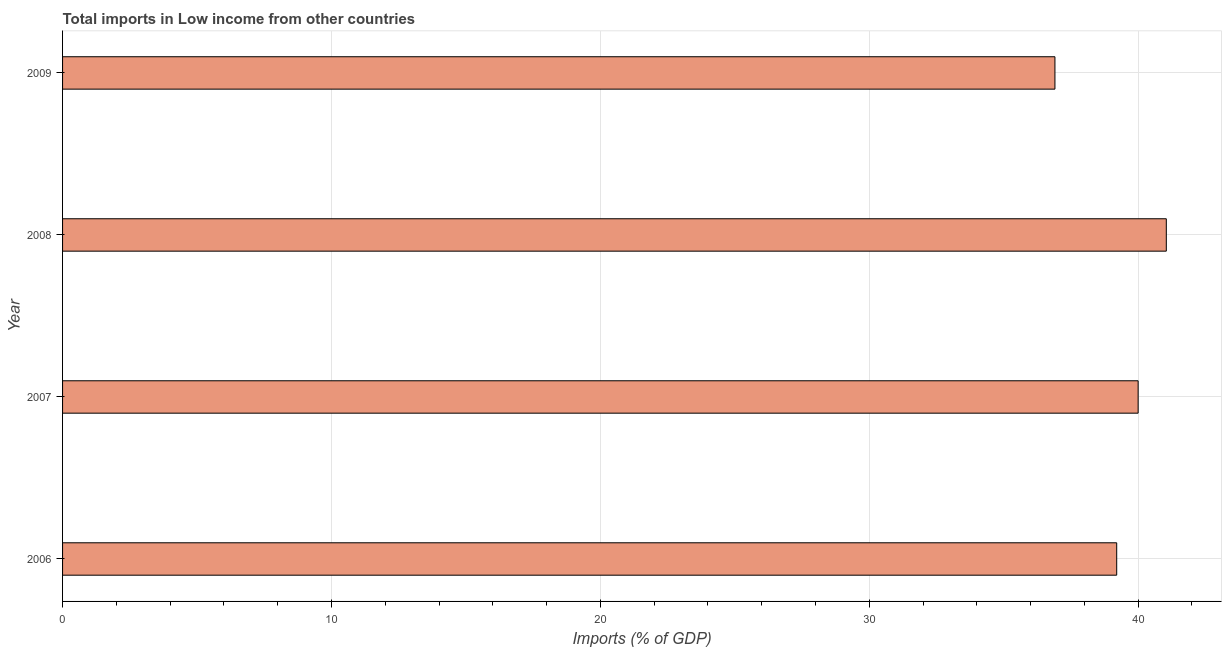Does the graph contain grids?
Your response must be concise. Yes. What is the title of the graph?
Offer a very short reply. Total imports in Low income from other countries. What is the label or title of the X-axis?
Ensure brevity in your answer.  Imports (% of GDP). What is the total imports in 2008?
Ensure brevity in your answer.  41.05. Across all years, what is the maximum total imports?
Offer a terse response. 41.05. Across all years, what is the minimum total imports?
Give a very brief answer. 36.91. In which year was the total imports maximum?
Offer a very short reply. 2008. In which year was the total imports minimum?
Offer a very short reply. 2009. What is the sum of the total imports?
Ensure brevity in your answer.  157.16. What is the difference between the total imports in 2007 and 2009?
Make the answer very short. 3.09. What is the average total imports per year?
Keep it short and to the point. 39.29. What is the median total imports?
Keep it short and to the point. 39.6. Do a majority of the years between 2009 and 2007 (inclusive) have total imports greater than 8 %?
Keep it short and to the point. Yes. What is the ratio of the total imports in 2006 to that in 2009?
Offer a very short reply. 1.06. Is the total imports in 2006 less than that in 2007?
Provide a short and direct response. Yes. Is the difference between the total imports in 2006 and 2007 greater than the difference between any two years?
Make the answer very short. No. What is the difference between the highest and the second highest total imports?
Give a very brief answer. 1.05. What is the difference between the highest and the lowest total imports?
Provide a short and direct response. 4.14. How many bars are there?
Offer a very short reply. 4. What is the difference between two consecutive major ticks on the X-axis?
Your answer should be compact. 10. Are the values on the major ticks of X-axis written in scientific E-notation?
Provide a succinct answer. No. What is the Imports (% of GDP) of 2006?
Your answer should be compact. 39.2. What is the Imports (% of GDP) of 2007?
Your answer should be very brief. 40. What is the Imports (% of GDP) of 2008?
Provide a succinct answer. 41.05. What is the Imports (% of GDP) of 2009?
Keep it short and to the point. 36.91. What is the difference between the Imports (% of GDP) in 2006 and 2007?
Keep it short and to the point. -0.8. What is the difference between the Imports (% of GDP) in 2006 and 2008?
Offer a terse response. -1.84. What is the difference between the Imports (% of GDP) in 2006 and 2009?
Offer a very short reply. 2.3. What is the difference between the Imports (% of GDP) in 2007 and 2008?
Provide a short and direct response. -1.05. What is the difference between the Imports (% of GDP) in 2007 and 2009?
Keep it short and to the point. 3.09. What is the difference between the Imports (% of GDP) in 2008 and 2009?
Keep it short and to the point. 4.14. What is the ratio of the Imports (% of GDP) in 2006 to that in 2007?
Your response must be concise. 0.98. What is the ratio of the Imports (% of GDP) in 2006 to that in 2008?
Your response must be concise. 0.95. What is the ratio of the Imports (% of GDP) in 2006 to that in 2009?
Provide a short and direct response. 1.06. What is the ratio of the Imports (% of GDP) in 2007 to that in 2008?
Make the answer very short. 0.97. What is the ratio of the Imports (% of GDP) in 2007 to that in 2009?
Provide a succinct answer. 1.08. What is the ratio of the Imports (% of GDP) in 2008 to that in 2009?
Make the answer very short. 1.11. 